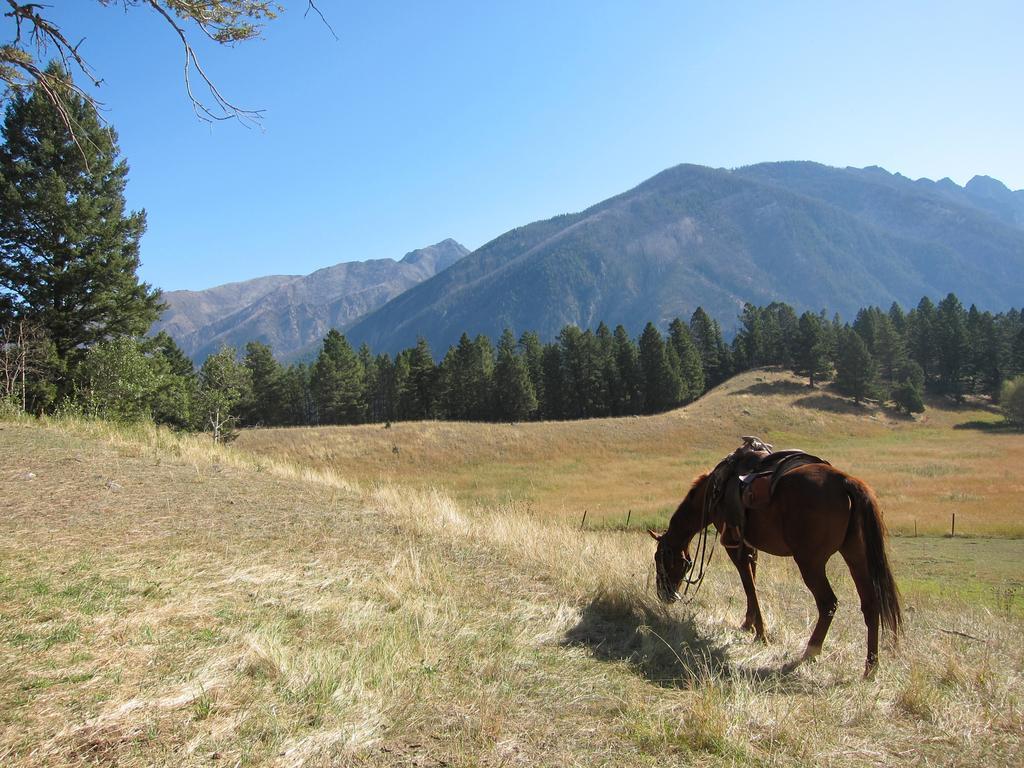Please provide a concise description of this image. In this image, we can see a horse on the right side, there's grass on the ground, we can see some trees, there are some mountains, at the top there is a blue sky. 